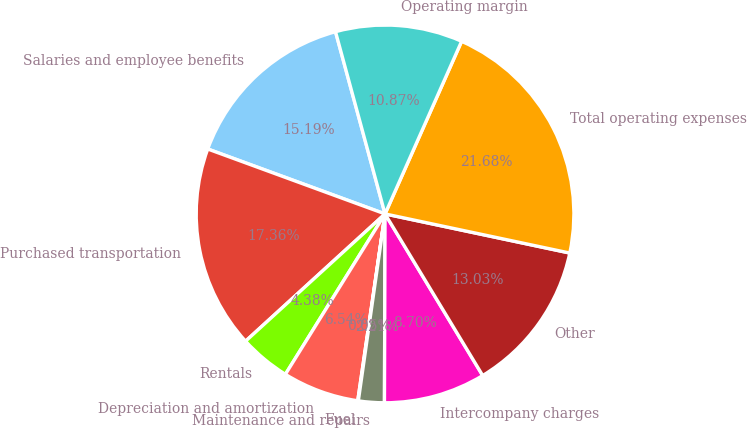Convert chart to OTSL. <chart><loc_0><loc_0><loc_500><loc_500><pie_chart><fcel>Salaries and employee benefits<fcel>Purchased transportation<fcel>Rentals<fcel>Depreciation and amortization<fcel>Fuel<fcel>Maintenance and repairs<fcel>Intercompany charges<fcel>Other<fcel>Total operating expenses<fcel>Operating margin<nl><fcel>15.19%<fcel>17.36%<fcel>4.38%<fcel>6.54%<fcel>0.05%<fcel>2.21%<fcel>8.7%<fcel>13.03%<fcel>21.68%<fcel>10.87%<nl></chart> 